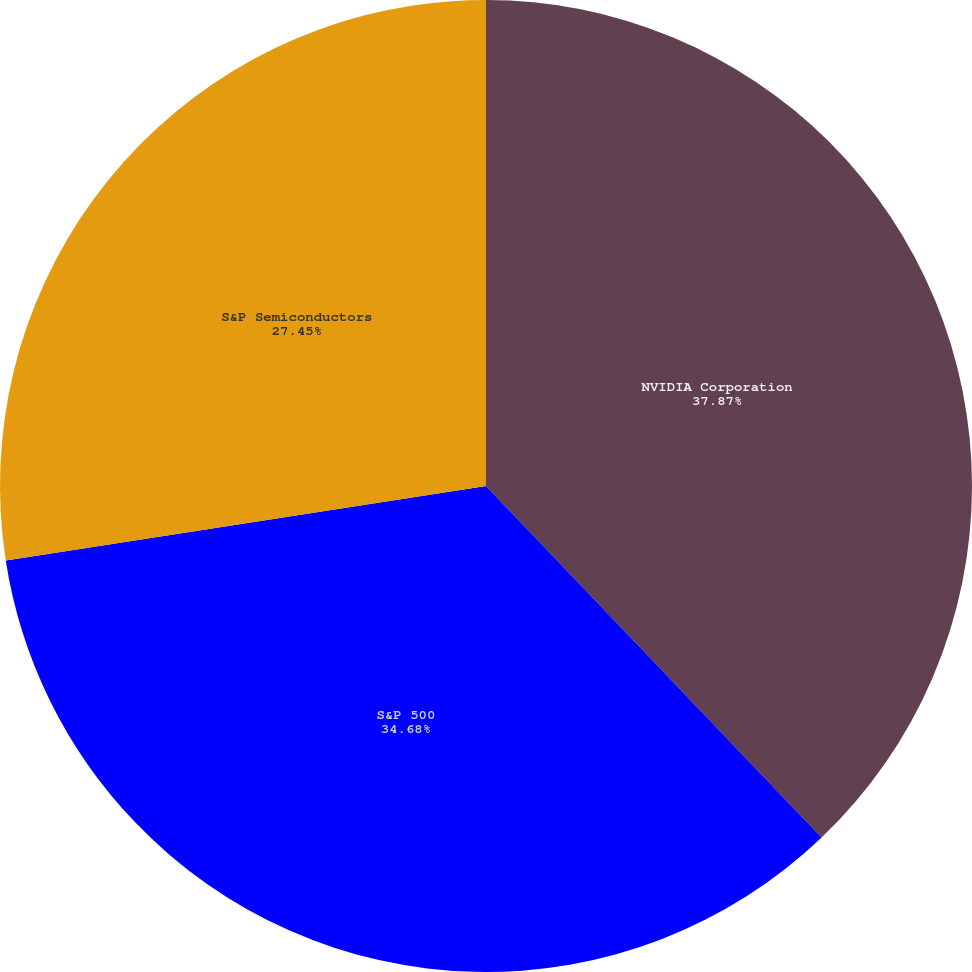<chart> <loc_0><loc_0><loc_500><loc_500><pie_chart><fcel>NVIDIA Corporation<fcel>S&P 500<fcel>S&P Semiconductors<nl><fcel>37.87%<fcel>34.68%<fcel>27.45%<nl></chart> 